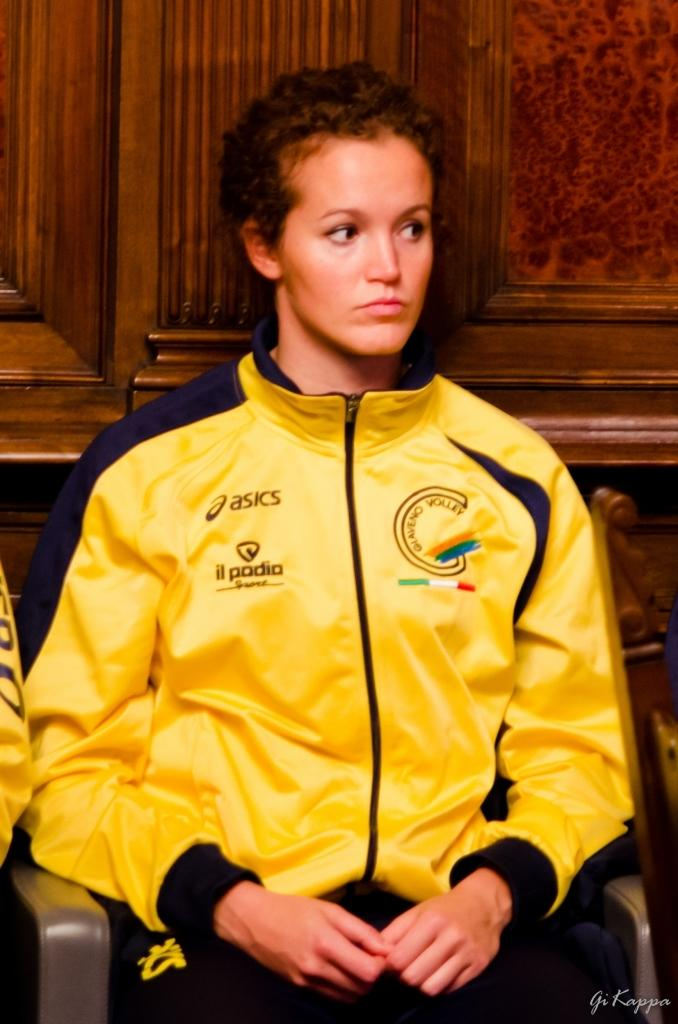<image>
Present a compact description of the photo's key features. Yellow Oasics jacket with  il padia design on the left side. 